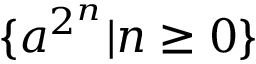Convert formula to latex. <formula><loc_0><loc_0><loc_500><loc_500>\{ a ^ { 2 ^ { n } } | n \geq 0 \}</formula> 